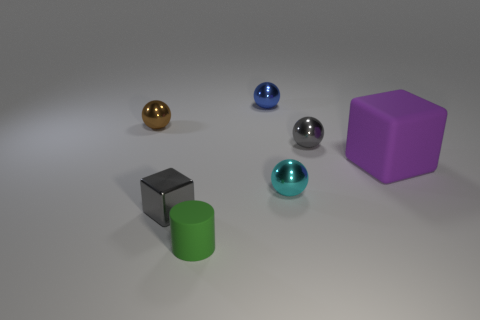Can you describe the lighting in this scene? The lighting in the scene is soft and diffuse, with a slight shadow being cast by the objects, indicating ambient light probably combined with a gentle directional source, creating a calm atmosphere that highlights the shapes and colors of the objects without causing harsh contrasts.  Are there any shadows indicating the direction of the light source? Yes, the shadows are subtly present under and slightly to the left side of the objects, suggesting the primary light source is above and slightly to the right of the scene. The shadows give a sense of the objects' position in space and their form. 